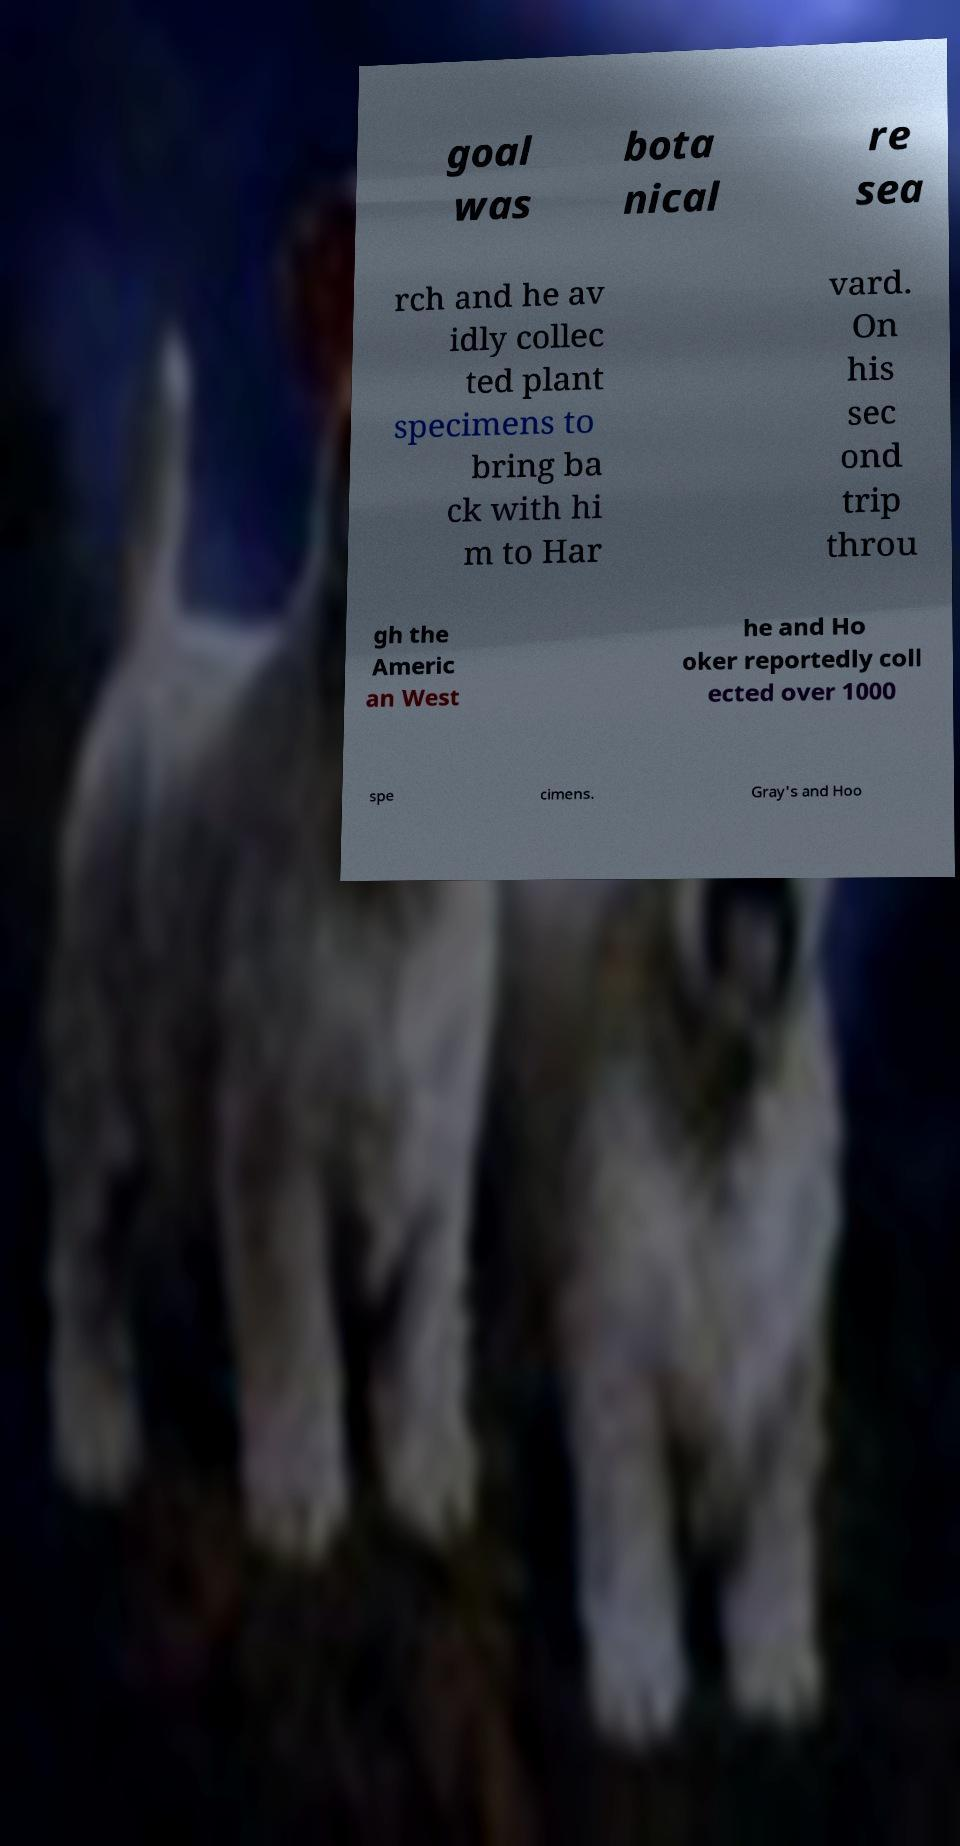What messages or text are displayed in this image? I need them in a readable, typed format. goal was bota nical re sea rch and he av idly collec ted plant specimens to bring ba ck with hi m to Har vard. On his sec ond trip throu gh the Americ an West he and Ho oker reportedly coll ected over 1000 spe cimens. Gray's and Hoo 